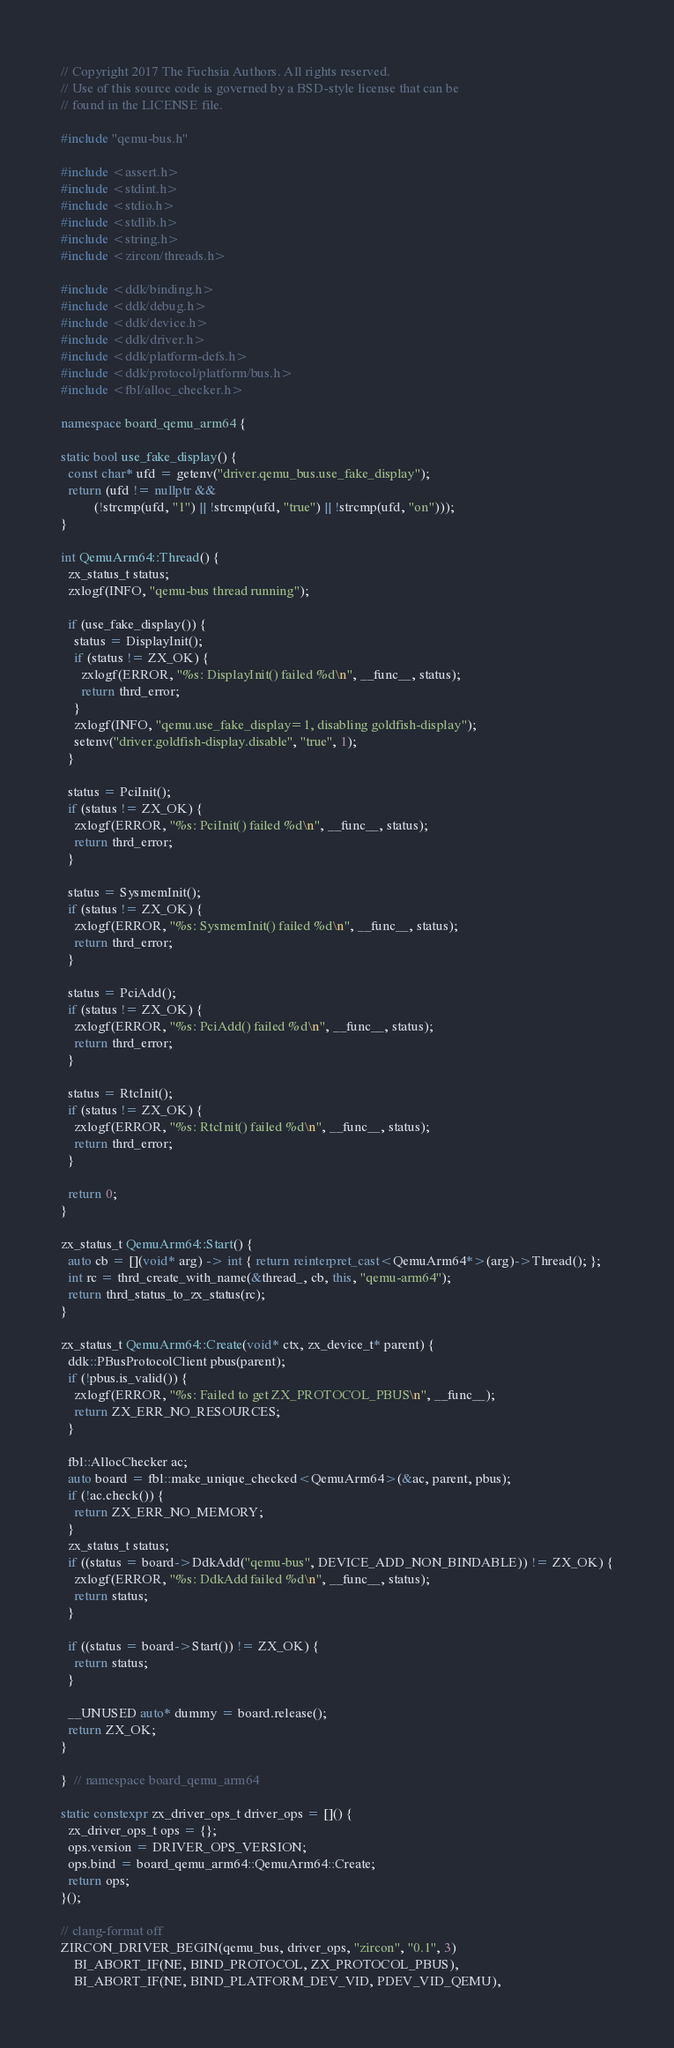Convert code to text. <code><loc_0><loc_0><loc_500><loc_500><_C++_>// Copyright 2017 The Fuchsia Authors. All rights reserved.
// Use of this source code is governed by a BSD-style license that can be
// found in the LICENSE file.

#include "qemu-bus.h"

#include <assert.h>
#include <stdint.h>
#include <stdio.h>
#include <stdlib.h>
#include <string.h>
#include <zircon/threads.h>

#include <ddk/binding.h>
#include <ddk/debug.h>
#include <ddk/device.h>
#include <ddk/driver.h>
#include <ddk/platform-defs.h>
#include <ddk/protocol/platform/bus.h>
#include <fbl/alloc_checker.h>

namespace board_qemu_arm64 {

static bool use_fake_display() {
  const char* ufd = getenv("driver.qemu_bus.use_fake_display");
  return (ufd != nullptr &&
          (!strcmp(ufd, "1") || !strcmp(ufd, "true") || !strcmp(ufd, "on")));
}

int QemuArm64::Thread() {
  zx_status_t status;
  zxlogf(INFO, "qemu-bus thread running");

  if (use_fake_display()) {
    status = DisplayInit();
    if (status != ZX_OK) {
      zxlogf(ERROR, "%s: DisplayInit() failed %d\n", __func__, status);
      return thrd_error;
    }
    zxlogf(INFO, "qemu.use_fake_display=1, disabling goldfish-display");
    setenv("driver.goldfish-display.disable", "true", 1);
  }

  status = PciInit();
  if (status != ZX_OK) {
    zxlogf(ERROR, "%s: PciInit() failed %d\n", __func__, status);
    return thrd_error;
  }

  status = SysmemInit();
  if (status != ZX_OK) {
    zxlogf(ERROR, "%s: SysmemInit() failed %d\n", __func__, status);
    return thrd_error;
  }

  status = PciAdd();
  if (status != ZX_OK) {
    zxlogf(ERROR, "%s: PciAdd() failed %d\n", __func__, status);
    return thrd_error;
  }

  status = RtcInit();
  if (status != ZX_OK) {
    zxlogf(ERROR, "%s: RtcInit() failed %d\n", __func__, status);
    return thrd_error;
  }

  return 0;
}

zx_status_t QemuArm64::Start() {
  auto cb = [](void* arg) -> int { return reinterpret_cast<QemuArm64*>(arg)->Thread(); };
  int rc = thrd_create_with_name(&thread_, cb, this, "qemu-arm64");
  return thrd_status_to_zx_status(rc);
}

zx_status_t QemuArm64::Create(void* ctx, zx_device_t* parent) {
  ddk::PBusProtocolClient pbus(parent);
  if (!pbus.is_valid()) {
    zxlogf(ERROR, "%s: Failed to get ZX_PROTOCOL_PBUS\n", __func__);
    return ZX_ERR_NO_RESOURCES;
  }

  fbl::AllocChecker ac;
  auto board = fbl::make_unique_checked<QemuArm64>(&ac, parent, pbus);
  if (!ac.check()) {
    return ZX_ERR_NO_MEMORY;
  }
  zx_status_t status;
  if ((status = board->DdkAdd("qemu-bus", DEVICE_ADD_NON_BINDABLE)) != ZX_OK) {
    zxlogf(ERROR, "%s: DdkAdd failed %d\n", __func__, status);
    return status;
  }

  if ((status = board->Start()) != ZX_OK) {
    return status;
  }

  __UNUSED auto* dummy = board.release();
  return ZX_OK;
}

}  // namespace board_qemu_arm64

static constexpr zx_driver_ops_t driver_ops = []() {
  zx_driver_ops_t ops = {};
  ops.version = DRIVER_OPS_VERSION;
  ops.bind = board_qemu_arm64::QemuArm64::Create;
  return ops;
}();

// clang-format off
ZIRCON_DRIVER_BEGIN(qemu_bus, driver_ops, "zircon", "0.1", 3)
    BI_ABORT_IF(NE, BIND_PROTOCOL, ZX_PROTOCOL_PBUS),
    BI_ABORT_IF(NE, BIND_PLATFORM_DEV_VID, PDEV_VID_QEMU),</code> 